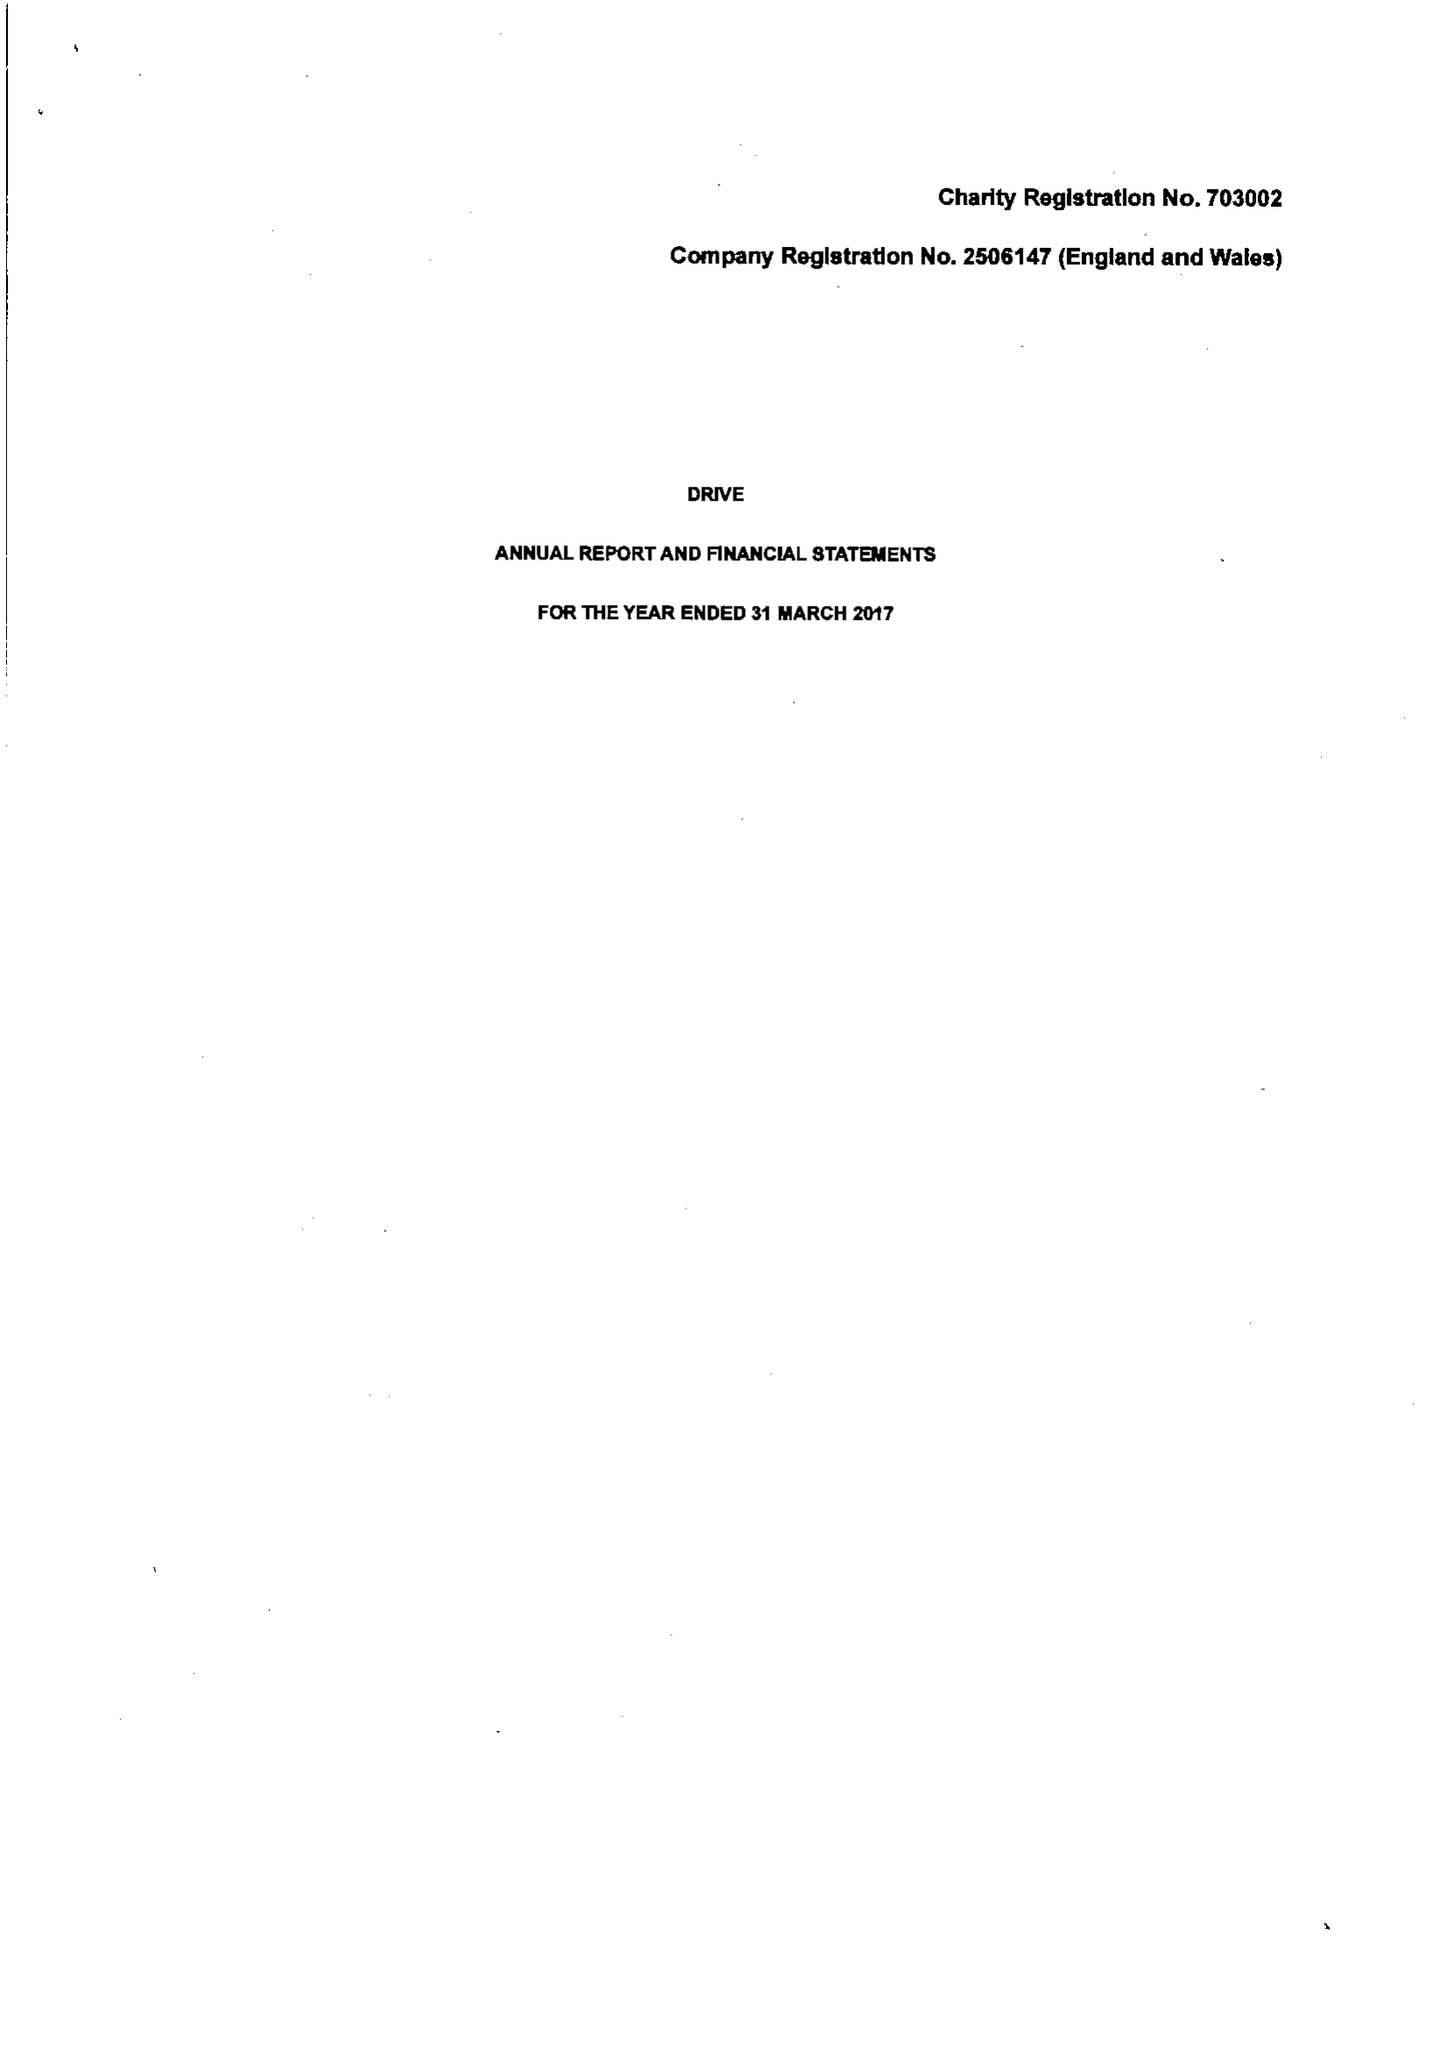What is the value for the spending_annually_in_british_pounds?
Answer the question using a single word or phrase. 13370845.00 